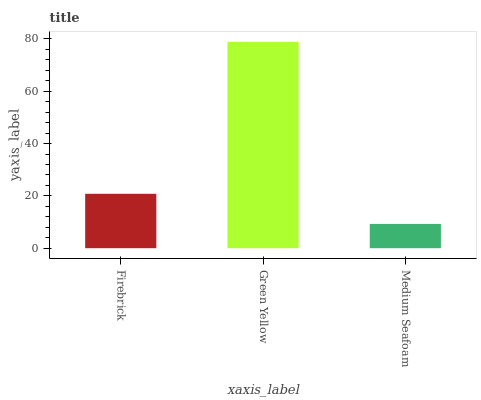Is Medium Seafoam the minimum?
Answer yes or no. Yes. Is Green Yellow the maximum?
Answer yes or no. Yes. Is Green Yellow the minimum?
Answer yes or no. No. Is Medium Seafoam the maximum?
Answer yes or no. No. Is Green Yellow greater than Medium Seafoam?
Answer yes or no. Yes. Is Medium Seafoam less than Green Yellow?
Answer yes or no. Yes. Is Medium Seafoam greater than Green Yellow?
Answer yes or no. No. Is Green Yellow less than Medium Seafoam?
Answer yes or no. No. Is Firebrick the high median?
Answer yes or no. Yes. Is Firebrick the low median?
Answer yes or no. Yes. Is Green Yellow the high median?
Answer yes or no. No. Is Medium Seafoam the low median?
Answer yes or no. No. 